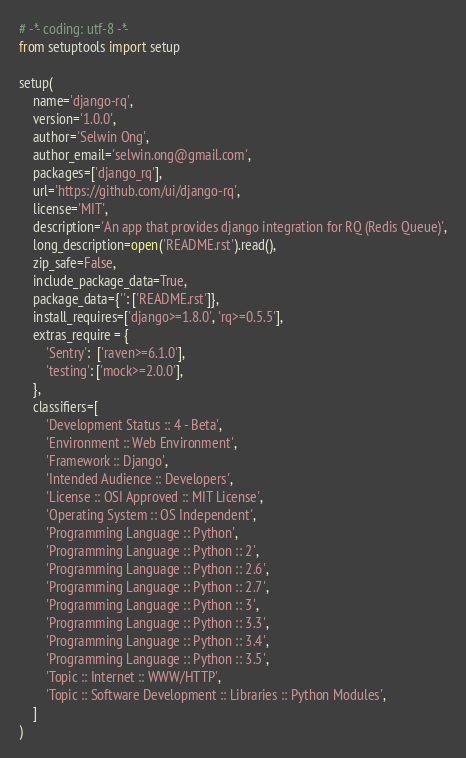<code> <loc_0><loc_0><loc_500><loc_500><_Python_># -*- coding: utf-8 -*-
from setuptools import setup

setup(
    name='django-rq',
    version='1.0.0',
    author='Selwin Ong',
    author_email='selwin.ong@gmail.com',
    packages=['django_rq'],
    url='https://github.com/ui/django-rq',
    license='MIT',
    description='An app that provides django integration for RQ (Redis Queue)',
    long_description=open('README.rst').read(),
    zip_safe=False,
    include_package_data=True,
    package_data={'': ['README.rst']},
    install_requires=['django>=1.8.0', 'rq>=0.5.5'],
    extras_require = {
        'Sentry':  ['raven>=6.1.0'],
        'testing': ['mock>=2.0.0'],
    },
    classifiers=[
        'Development Status :: 4 - Beta',
        'Environment :: Web Environment',
        'Framework :: Django',
        'Intended Audience :: Developers',
        'License :: OSI Approved :: MIT License',
        'Operating System :: OS Independent',
        'Programming Language :: Python',
        'Programming Language :: Python :: 2',
        'Programming Language :: Python :: 2.6',
        'Programming Language :: Python :: 2.7',
        'Programming Language :: Python :: 3',
        'Programming Language :: Python :: 3.3',
        'Programming Language :: Python :: 3.4',
        'Programming Language :: Python :: 3.5',
        'Topic :: Internet :: WWW/HTTP',
        'Topic :: Software Development :: Libraries :: Python Modules',
    ]
)
</code> 